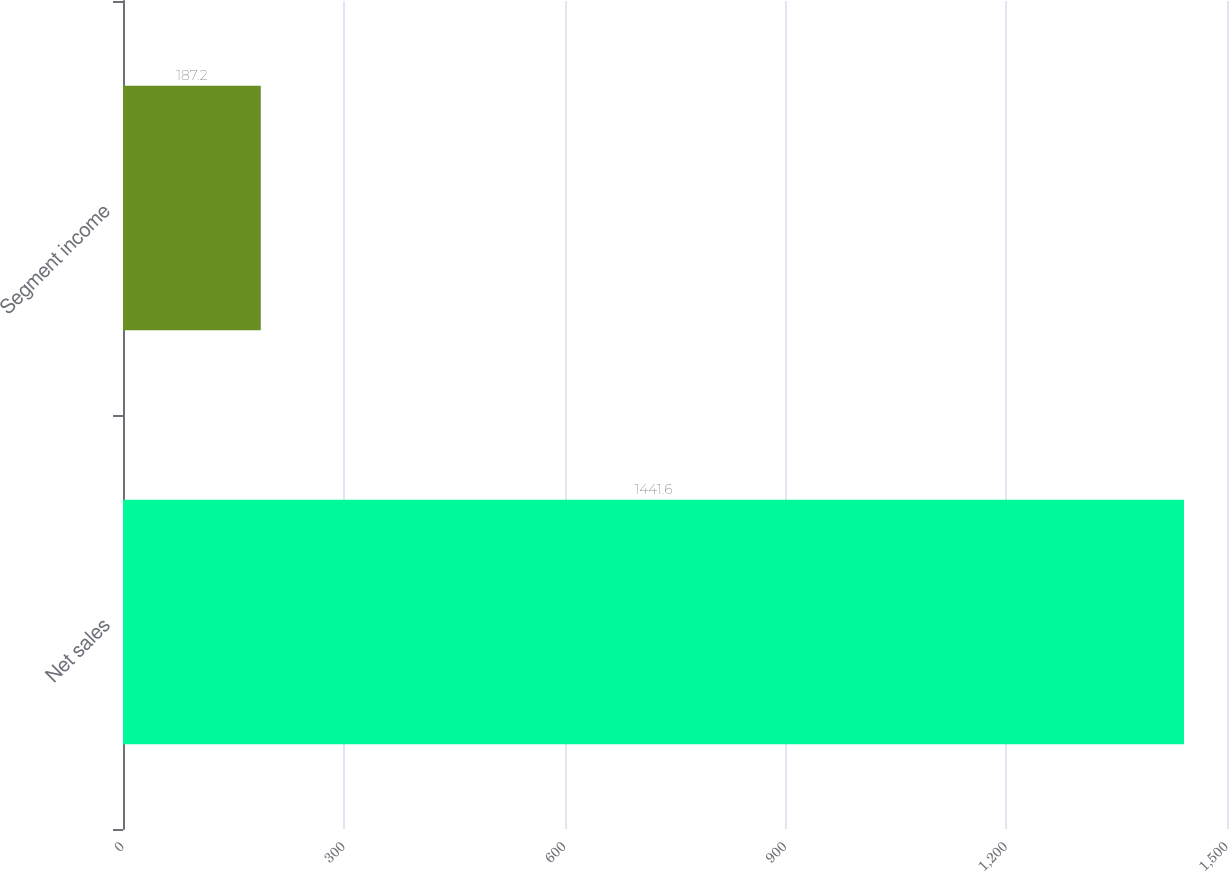<chart> <loc_0><loc_0><loc_500><loc_500><bar_chart><fcel>Net sales<fcel>Segment income<nl><fcel>1441.6<fcel>187.2<nl></chart> 